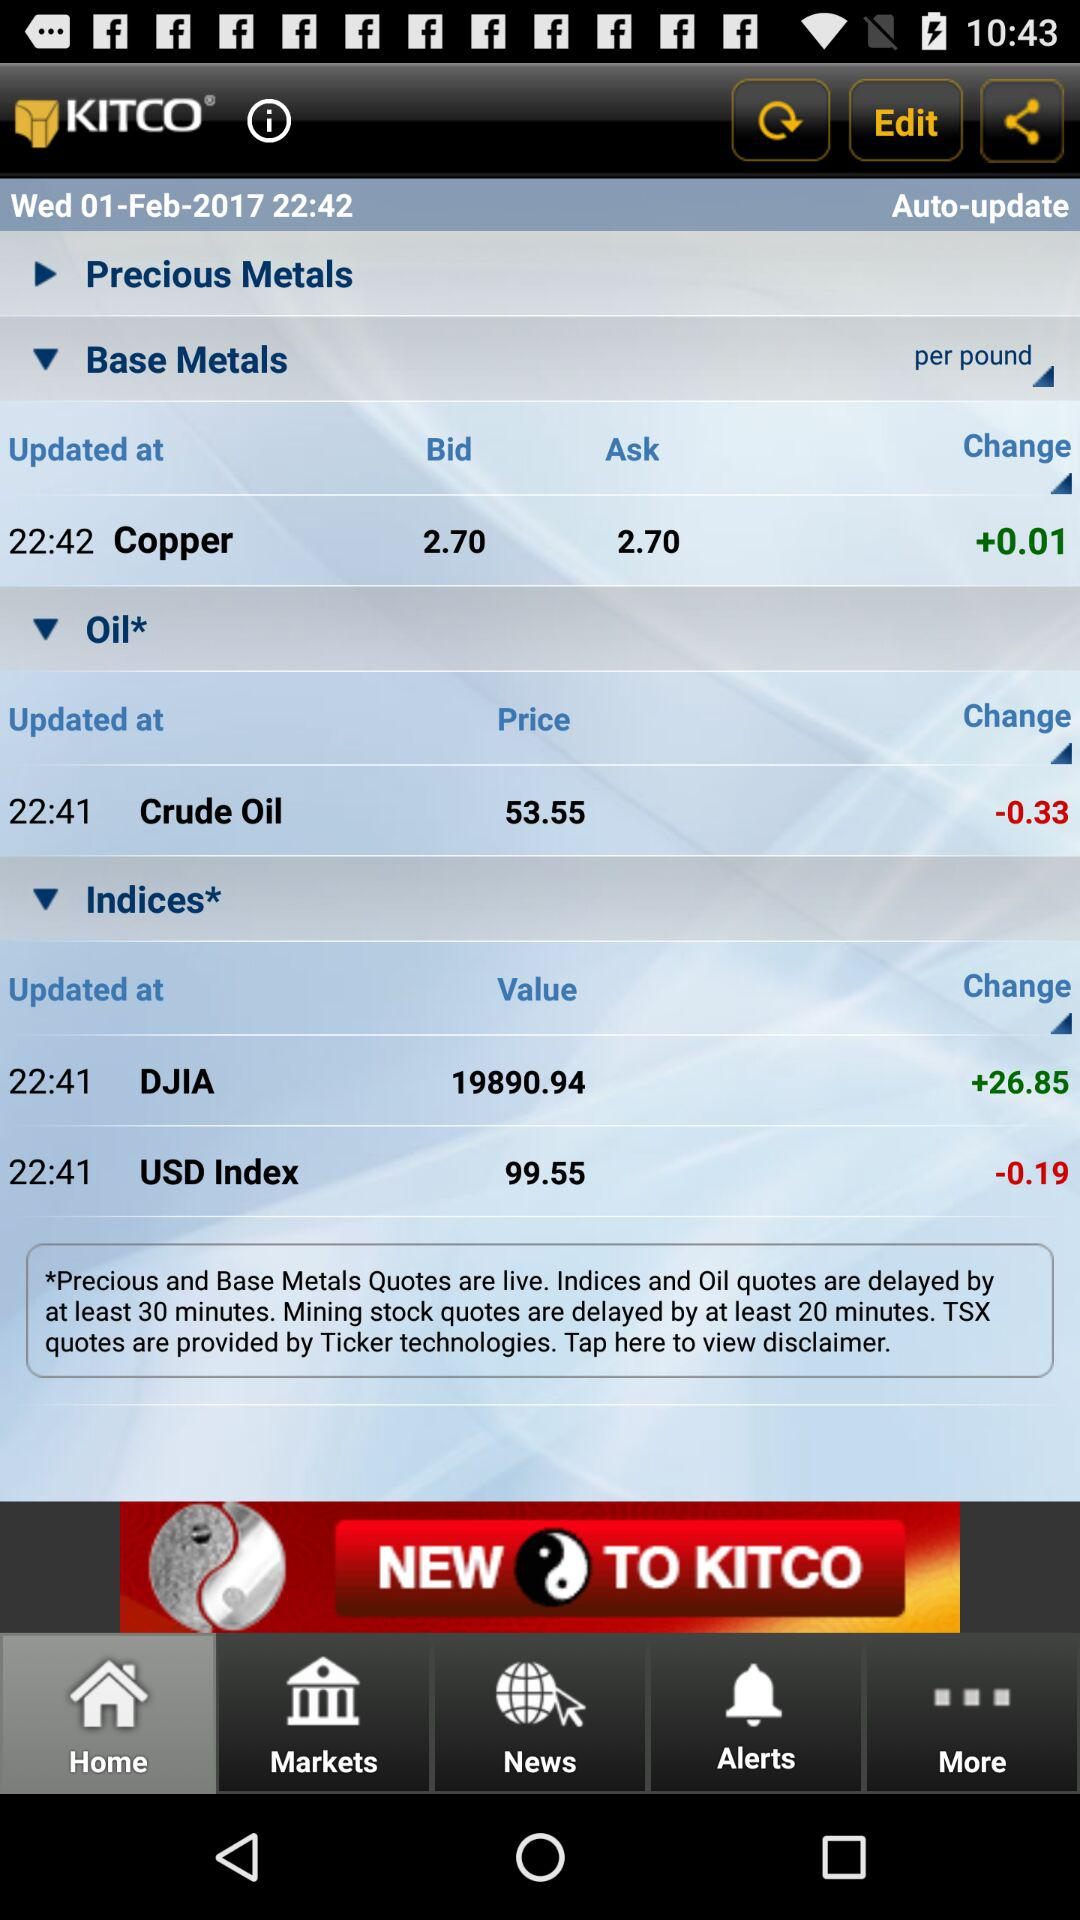What date is reflected on the screen? The date is Wednesday, February 1, 2017. 